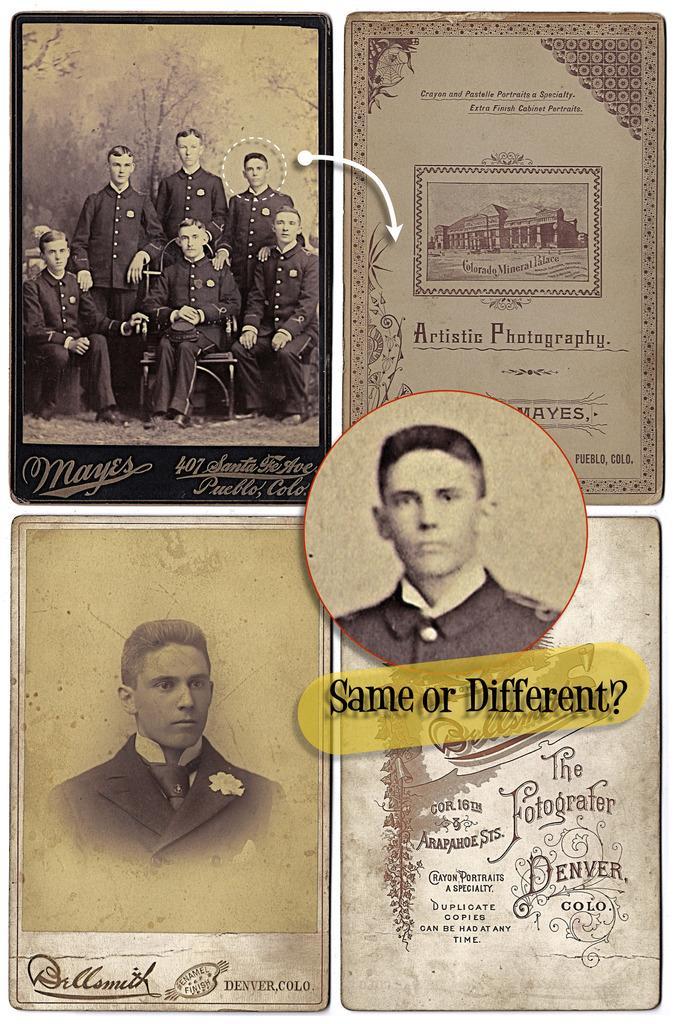Can you describe this image briefly? This image consists of four posters in which there are persons wearing black dress. To the right, it looks like a certificate. 